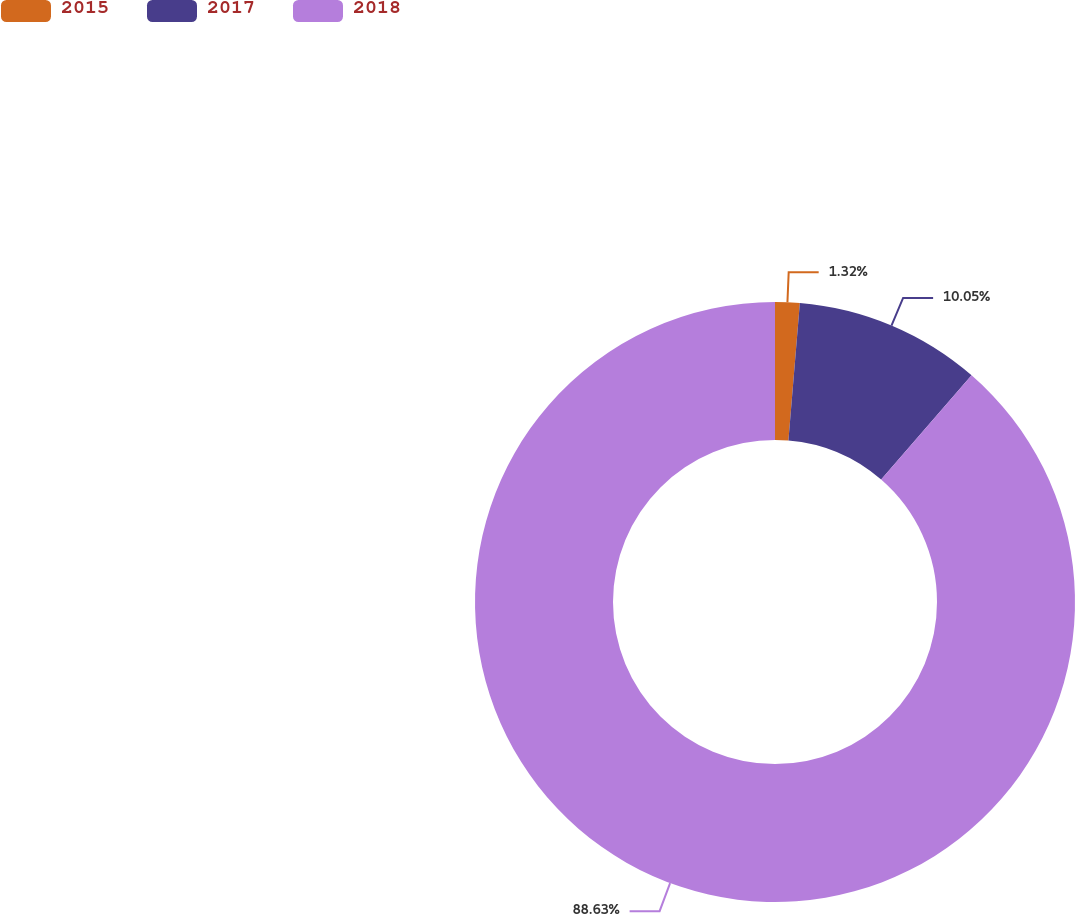Convert chart to OTSL. <chart><loc_0><loc_0><loc_500><loc_500><pie_chart><fcel>2015<fcel>2017<fcel>2018<nl><fcel>1.32%<fcel>10.05%<fcel>88.62%<nl></chart> 